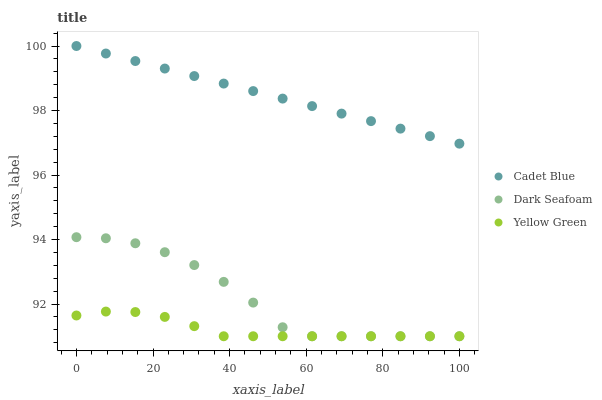Does Yellow Green have the minimum area under the curve?
Answer yes or no. Yes. Does Cadet Blue have the maximum area under the curve?
Answer yes or no. Yes. Does Cadet Blue have the minimum area under the curve?
Answer yes or no. No. Does Yellow Green have the maximum area under the curve?
Answer yes or no. No. Is Cadet Blue the smoothest?
Answer yes or no. Yes. Is Dark Seafoam the roughest?
Answer yes or no. Yes. Is Yellow Green the smoothest?
Answer yes or no. No. Is Yellow Green the roughest?
Answer yes or no. No. Does Dark Seafoam have the lowest value?
Answer yes or no. Yes. Does Cadet Blue have the lowest value?
Answer yes or no. No. Does Cadet Blue have the highest value?
Answer yes or no. Yes. Does Yellow Green have the highest value?
Answer yes or no. No. Is Dark Seafoam less than Cadet Blue?
Answer yes or no. Yes. Is Cadet Blue greater than Yellow Green?
Answer yes or no. Yes. Does Dark Seafoam intersect Yellow Green?
Answer yes or no. Yes. Is Dark Seafoam less than Yellow Green?
Answer yes or no. No. Is Dark Seafoam greater than Yellow Green?
Answer yes or no. No. Does Dark Seafoam intersect Cadet Blue?
Answer yes or no. No. 